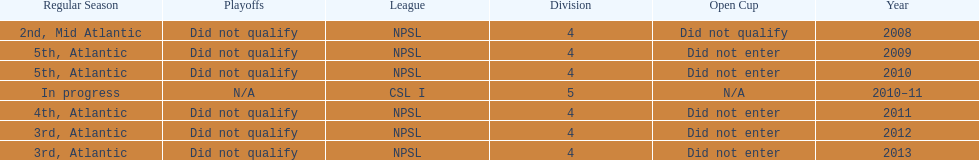What is the count of npsl's 3rd place finishes? 2. 